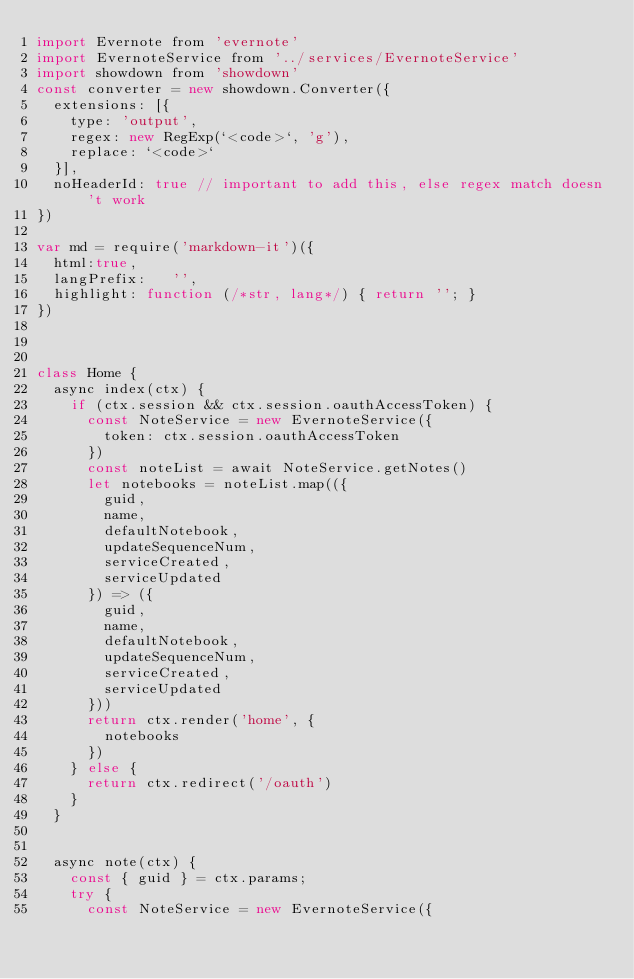Convert code to text. <code><loc_0><loc_0><loc_500><loc_500><_JavaScript_>import Evernote from 'evernote'
import EvernoteService from '../services/EvernoteService'
import showdown from 'showdown'
const converter = new showdown.Converter({
  extensions: [{
    type: 'output',
    regex: new RegExp(`<code>`, 'g'),
    replace: `<code>`
  }],
  noHeaderId: true // important to add this, else regex match doesn't work
})

var md = require('markdown-it')({
  html:true,
  langPrefix:   '',
  highlight: function (/*str, lang*/) { return ''; }
})



class Home {
  async index(ctx) {
    if (ctx.session && ctx.session.oauthAccessToken) {
      const NoteService = new EvernoteService({
        token: ctx.session.oauthAccessToken
      })
      const noteList = await NoteService.getNotes()
      let notebooks = noteList.map(({
        guid,
        name,
        defaultNotebook,
        updateSequenceNum,
        serviceCreated,
        serviceUpdated
      }) => ({
        guid,
        name,
        defaultNotebook,
        updateSequenceNum,
        serviceCreated,
        serviceUpdated
      }))
      return ctx.render('home', {
        notebooks
      })
    } else {
      return ctx.redirect('/oauth')
    }
  }


  async note(ctx) {
    const { guid } = ctx.params;
    try {
      const NoteService = new EvernoteService({</code> 